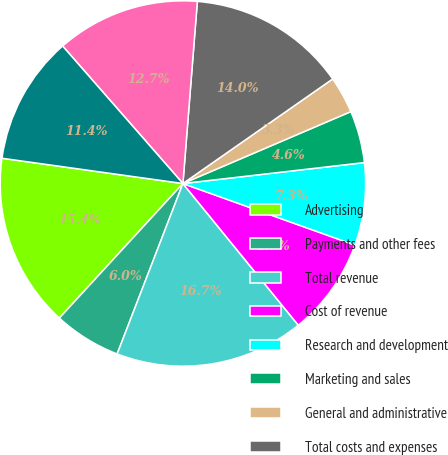Convert chart. <chart><loc_0><loc_0><loc_500><loc_500><pie_chart><fcel>Advertising<fcel>Payments and other fees<fcel>Total revenue<fcel>Cost of revenue<fcel>Research and development<fcel>Marketing and sales<fcel>General and administrative<fcel>Total costs and expenses<fcel>Income (loss) from operations<fcel>Income (loss) before provision<nl><fcel>15.39%<fcel>5.96%<fcel>16.74%<fcel>8.65%<fcel>7.3%<fcel>4.61%<fcel>3.26%<fcel>14.04%<fcel>12.7%<fcel>11.35%<nl></chart> 